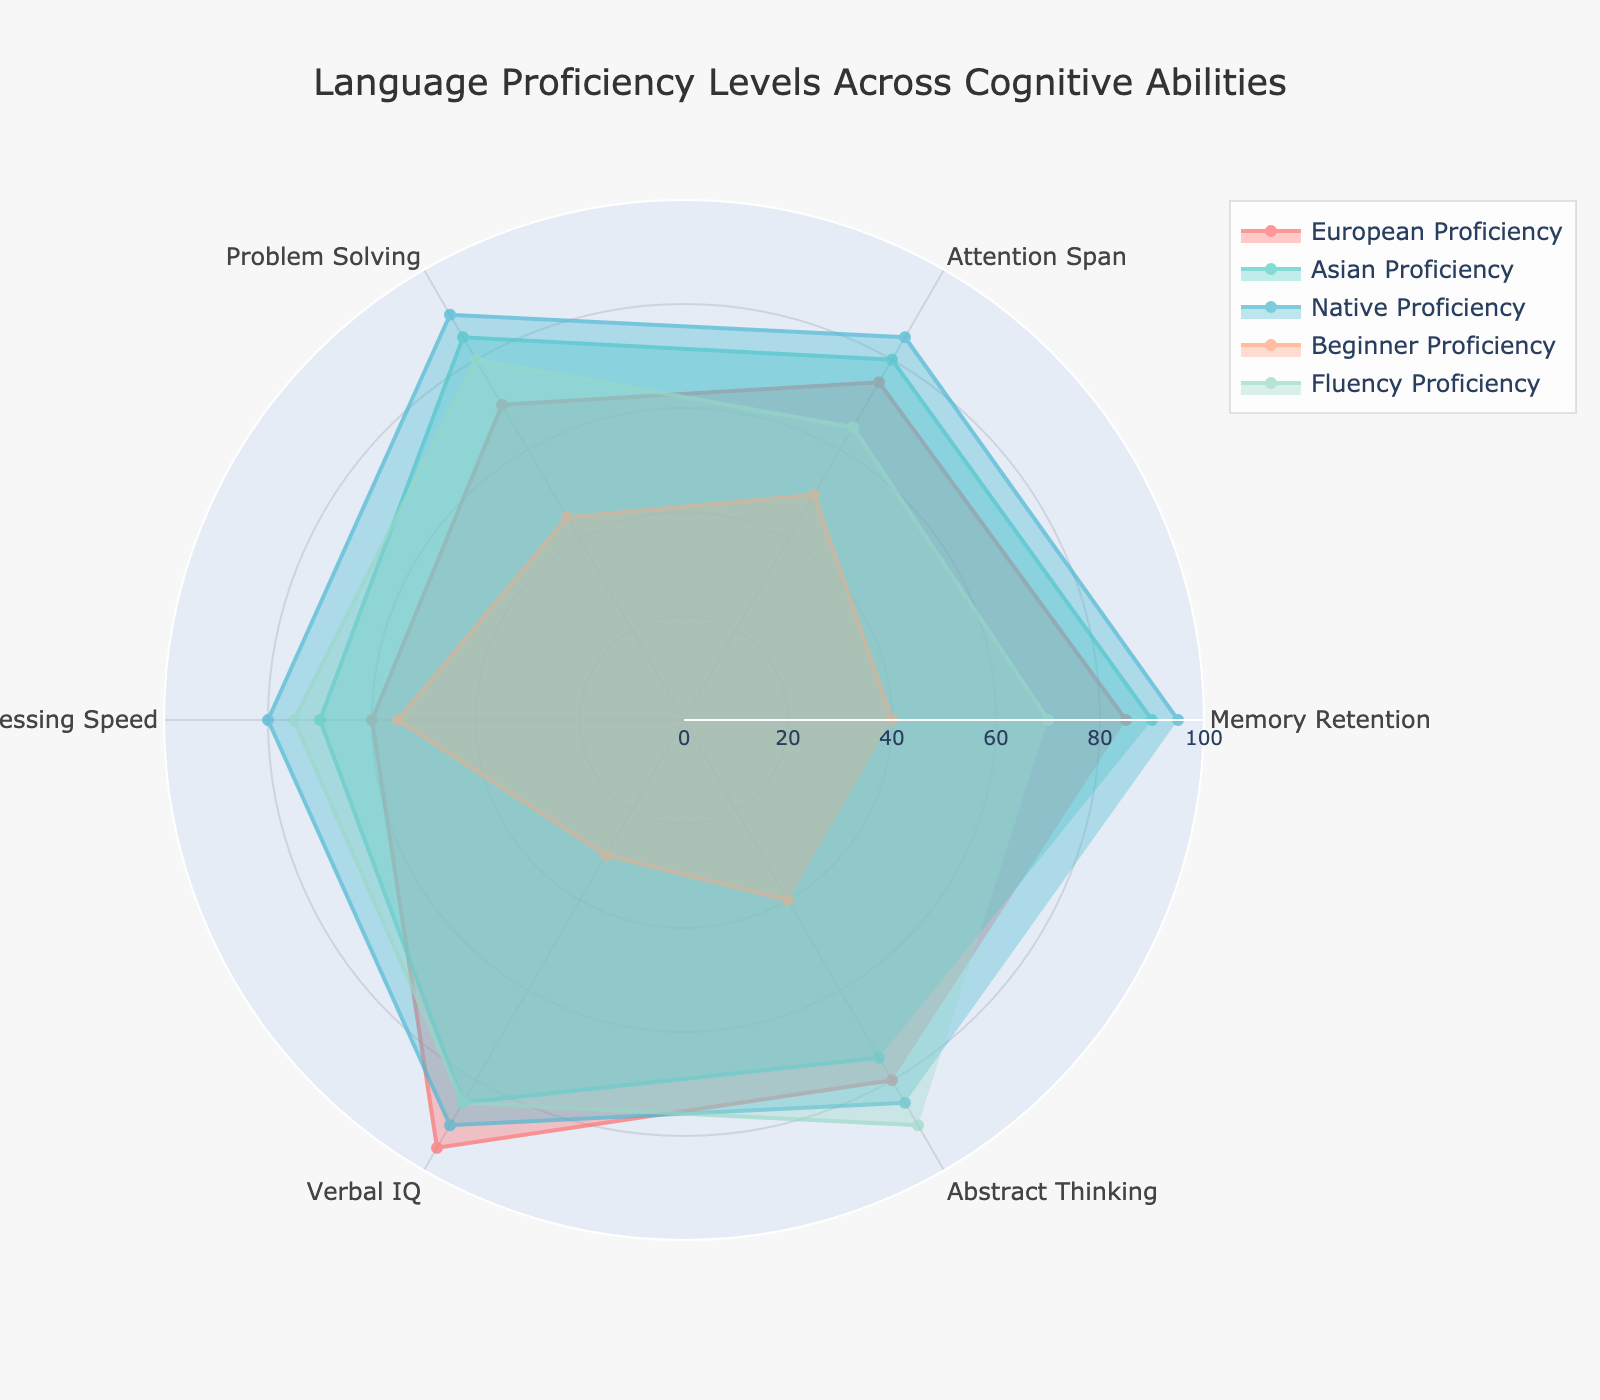What is the title of the radar chart? The title is the boldest text at the top of the chart, intended to summarize the chart's content. It reads "Language Proficiency Levels Across Cognitive Abilities".
Answer: Language Proficiency Levels Across Cognitive Abilities How many proficiency types are shown in the radar chart? Each proficiency type is represented by a different color and has a label in the legend. Counting these labels will give the number of proficiency types.
Answer: Five Which cognitive ability has the highest value for Native Proficiency? Look for the point on the radar chart where the Native Proficiency line (one specific color) reaches its maximum value. This can be identified as the longest radial line for Native Proficiency.
Answer: Memory Retention What is the difference between the highest and lowest scores of Verbal IQ across different proficiencies? Identify the highest and lowest values given for Verbal IQ in the chart, then subtract the lowest from the highest: Max value is 95, and min value is 30. Difference = 95 - 30.
Answer: 65 Which proficiency type shows the greatest variation in scores across all cognitive abilities? Calculate the range for each proficiency type by finding the difference between the maximum and minimum scores in each group. Identify the proficiency type with the largest range.
Answer: Verbal IQ How does Processing Speed compare from Beginner Proficiency to Fluency Proficiency? Look at the scores of Processing Speed for both Beginner and Fluency Proficiency, then compare the two values.
Answer: Beginner Proficiency: 55, Fluency Proficiency: 75; Fluency Proficiency is higher What is the average Attention Span score across all proficiency levels? Sum all the Attention Span scores and divide by the number of proficiency types: (75 + 80 + 85 + 50 + 65) / 5.
Answer: 71 Which cognitive ability has the most consistent score across all proficiency types? Evaluate the data to see which cognitive ability has the smallest variation (range) between its maximum and minimum scores across all proficiency types.
Answer: Attention Span Compare the scores of Abstract Thinking for European Proficiency and Asian Proficiency. Which is higher and by how much? Identify and subtract the scores for Abstract Thinking of both groups: European Proficiency (80) and Asian Proficiency (75).
Answer: European Proficiency, higher by 5 In which cognitive ability does Beginner Proficiency have a higher score than Native Proficiency? Compare scores of each cognitive ability for Beginner and Native Proficiency to check where Beginner Proficiency is higher.
Answer: Processing Speed 